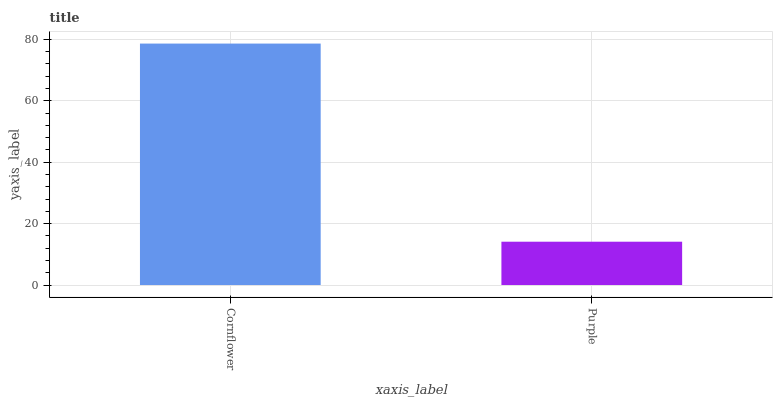Is Purple the minimum?
Answer yes or no. Yes. Is Cornflower the maximum?
Answer yes or no. Yes. Is Purple the maximum?
Answer yes or no. No. Is Cornflower greater than Purple?
Answer yes or no. Yes. Is Purple less than Cornflower?
Answer yes or no. Yes. Is Purple greater than Cornflower?
Answer yes or no. No. Is Cornflower less than Purple?
Answer yes or no. No. Is Cornflower the high median?
Answer yes or no. Yes. Is Purple the low median?
Answer yes or no. Yes. Is Purple the high median?
Answer yes or no. No. Is Cornflower the low median?
Answer yes or no. No. 